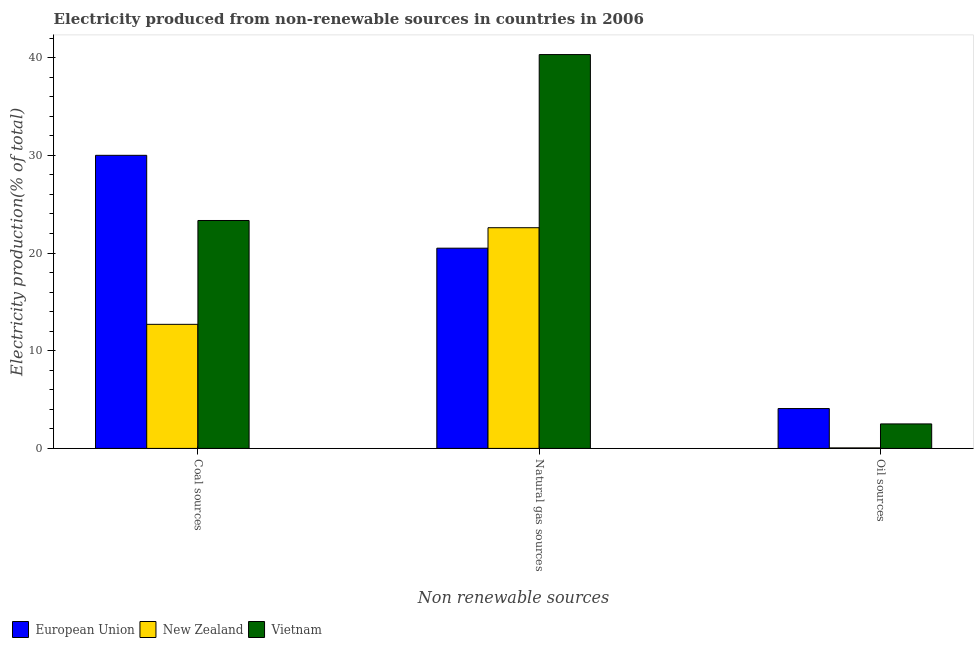How many different coloured bars are there?
Keep it short and to the point. 3. How many groups of bars are there?
Give a very brief answer. 3. Are the number of bars on each tick of the X-axis equal?
Offer a terse response. Yes. How many bars are there on the 3rd tick from the left?
Your answer should be very brief. 3. What is the label of the 3rd group of bars from the left?
Your response must be concise. Oil sources. What is the percentage of electricity produced by natural gas in Vietnam?
Ensure brevity in your answer.  40.32. Across all countries, what is the maximum percentage of electricity produced by oil sources?
Offer a terse response. 4.08. Across all countries, what is the minimum percentage of electricity produced by oil sources?
Your answer should be compact. 0.05. In which country was the percentage of electricity produced by oil sources maximum?
Offer a terse response. European Union. In which country was the percentage of electricity produced by coal minimum?
Make the answer very short. New Zealand. What is the total percentage of electricity produced by oil sources in the graph?
Offer a terse response. 6.64. What is the difference between the percentage of electricity produced by oil sources in European Union and that in New Zealand?
Offer a very short reply. 4.03. What is the difference between the percentage of electricity produced by oil sources in European Union and the percentage of electricity produced by natural gas in New Zealand?
Keep it short and to the point. -18.51. What is the average percentage of electricity produced by natural gas per country?
Your answer should be compact. 27.8. What is the difference between the percentage of electricity produced by coal and percentage of electricity produced by natural gas in Vietnam?
Offer a very short reply. -16.99. What is the ratio of the percentage of electricity produced by coal in New Zealand to that in European Union?
Provide a succinct answer. 0.42. What is the difference between the highest and the second highest percentage of electricity produced by natural gas?
Your answer should be very brief. 17.72. What is the difference between the highest and the lowest percentage of electricity produced by coal?
Ensure brevity in your answer.  17.3. In how many countries, is the percentage of electricity produced by coal greater than the average percentage of electricity produced by coal taken over all countries?
Your response must be concise. 2. Is the sum of the percentage of electricity produced by oil sources in Vietnam and New Zealand greater than the maximum percentage of electricity produced by natural gas across all countries?
Provide a succinct answer. No. What does the 3rd bar from the left in Natural gas sources represents?
Offer a terse response. Vietnam. What does the 2nd bar from the right in Natural gas sources represents?
Provide a short and direct response. New Zealand. Is it the case that in every country, the sum of the percentage of electricity produced by coal and percentage of electricity produced by natural gas is greater than the percentage of electricity produced by oil sources?
Offer a very short reply. Yes. How many bars are there?
Offer a terse response. 9. Are all the bars in the graph horizontal?
Offer a very short reply. No. Are the values on the major ticks of Y-axis written in scientific E-notation?
Give a very brief answer. No. Does the graph contain any zero values?
Give a very brief answer. No. Does the graph contain grids?
Make the answer very short. No. Where does the legend appear in the graph?
Make the answer very short. Bottom left. How many legend labels are there?
Your answer should be compact. 3. How are the legend labels stacked?
Your answer should be compact. Horizontal. What is the title of the graph?
Your answer should be very brief. Electricity produced from non-renewable sources in countries in 2006. Does "Haiti" appear as one of the legend labels in the graph?
Your answer should be very brief. No. What is the label or title of the X-axis?
Give a very brief answer. Non renewable sources. What is the Electricity production(% of total) of European Union in Coal sources?
Offer a terse response. 30. What is the Electricity production(% of total) of New Zealand in Coal sources?
Provide a succinct answer. 12.7. What is the Electricity production(% of total) in Vietnam in Coal sources?
Provide a succinct answer. 23.33. What is the Electricity production(% of total) of European Union in Natural gas sources?
Ensure brevity in your answer.  20.5. What is the Electricity production(% of total) of New Zealand in Natural gas sources?
Make the answer very short. 22.59. What is the Electricity production(% of total) in Vietnam in Natural gas sources?
Your answer should be compact. 40.32. What is the Electricity production(% of total) in European Union in Oil sources?
Offer a very short reply. 4.08. What is the Electricity production(% of total) of New Zealand in Oil sources?
Your response must be concise. 0.05. What is the Electricity production(% of total) in Vietnam in Oil sources?
Give a very brief answer. 2.51. Across all Non renewable sources, what is the maximum Electricity production(% of total) of European Union?
Make the answer very short. 30. Across all Non renewable sources, what is the maximum Electricity production(% of total) of New Zealand?
Your response must be concise. 22.59. Across all Non renewable sources, what is the maximum Electricity production(% of total) of Vietnam?
Give a very brief answer. 40.32. Across all Non renewable sources, what is the minimum Electricity production(% of total) of European Union?
Your answer should be very brief. 4.08. Across all Non renewable sources, what is the minimum Electricity production(% of total) in New Zealand?
Provide a short and direct response. 0.05. Across all Non renewable sources, what is the minimum Electricity production(% of total) in Vietnam?
Offer a very short reply. 2.51. What is the total Electricity production(% of total) of European Union in the graph?
Ensure brevity in your answer.  54.58. What is the total Electricity production(% of total) of New Zealand in the graph?
Ensure brevity in your answer.  35.35. What is the total Electricity production(% of total) in Vietnam in the graph?
Offer a very short reply. 66.16. What is the difference between the Electricity production(% of total) of European Union in Coal sources and that in Natural gas sources?
Ensure brevity in your answer.  9.51. What is the difference between the Electricity production(% of total) of New Zealand in Coal sources and that in Natural gas sources?
Keep it short and to the point. -9.89. What is the difference between the Electricity production(% of total) in Vietnam in Coal sources and that in Natural gas sources?
Your answer should be very brief. -16.99. What is the difference between the Electricity production(% of total) of European Union in Coal sources and that in Oil sources?
Provide a short and direct response. 25.92. What is the difference between the Electricity production(% of total) in New Zealand in Coal sources and that in Oil sources?
Provide a short and direct response. 12.65. What is the difference between the Electricity production(% of total) in Vietnam in Coal sources and that in Oil sources?
Your answer should be compact. 20.82. What is the difference between the Electricity production(% of total) of European Union in Natural gas sources and that in Oil sources?
Give a very brief answer. 16.42. What is the difference between the Electricity production(% of total) of New Zealand in Natural gas sources and that in Oil sources?
Give a very brief answer. 22.54. What is the difference between the Electricity production(% of total) of Vietnam in Natural gas sources and that in Oil sources?
Keep it short and to the point. 37.81. What is the difference between the Electricity production(% of total) in European Union in Coal sources and the Electricity production(% of total) in New Zealand in Natural gas sources?
Keep it short and to the point. 7.41. What is the difference between the Electricity production(% of total) of European Union in Coal sources and the Electricity production(% of total) of Vietnam in Natural gas sources?
Provide a succinct answer. -10.31. What is the difference between the Electricity production(% of total) in New Zealand in Coal sources and the Electricity production(% of total) in Vietnam in Natural gas sources?
Your response must be concise. -27.62. What is the difference between the Electricity production(% of total) in European Union in Coal sources and the Electricity production(% of total) in New Zealand in Oil sources?
Provide a short and direct response. 29.95. What is the difference between the Electricity production(% of total) in European Union in Coal sources and the Electricity production(% of total) in Vietnam in Oil sources?
Offer a terse response. 27.5. What is the difference between the Electricity production(% of total) in New Zealand in Coal sources and the Electricity production(% of total) in Vietnam in Oil sources?
Provide a succinct answer. 10.19. What is the difference between the Electricity production(% of total) of European Union in Natural gas sources and the Electricity production(% of total) of New Zealand in Oil sources?
Provide a short and direct response. 20.44. What is the difference between the Electricity production(% of total) of European Union in Natural gas sources and the Electricity production(% of total) of Vietnam in Oil sources?
Offer a terse response. 17.99. What is the difference between the Electricity production(% of total) of New Zealand in Natural gas sources and the Electricity production(% of total) of Vietnam in Oil sources?
Provide a short and direct response. 20.09. What is the average Electricity production(% of total) in European Union per Non renewable sources?
Offer a very short reply. 18.19. What is the average Electricity production(% of total) in New Zealand per Non renewable sources?
Make the answer very short. 11.78. What is the average Electricity production(% of total) in Vietnam per Non renewable sources?
Your answer should be very brief. 22.05. What is the difference between the Electricity production(% of total) of European Union and Electricity production(% of total) of New Zealand in Coal sources?
Provide a succinct answer. 17.3. What is the difference between the Electricity production(% of total) in European Union and Electricity production(% of total) in Vietnam in Coal sources?
Ensure brevity in your answer.  6.67. What is the difference between the Electricity production(% of total) of New Zealand and Electricity production(% of total) of Vietnam in Coal sources?
Ensure brevity in your answer.  -10.63. What is the difference between the Electricity production(% of total) in European Union and Electricity production(% of total) in New Zealand in Natural gas sources?
Provide a succinct answer. -2.1. What is the difference between the Electricity production(% of total) of European Union and Electricity production(% of total) of Vietnam in Natural gas sources?
Offer a terse response. -19.82. What is the difference between the Electricity production(% of total) in New Zealand and Electricity production(% of total) in Vietnam in Natural gas sources?
Offer a terse response. -17.72. What is the difference between the Electricity production(% of total) in European Union and Electricity production(% of total) in New Zealand in Oil sources?
Your answer should be very brief. 4.03. What is the difference between the Electricity production(% of total) in European Union and Electricity production(% of total) in Vietnam in Oil sources?
Ensure brevity in your answer.  1.57. What is the difference between the Electricity production(% of total) of New Zealand and Electricity production(% of total) of Vietnam in Oil sources?
Give a very brief answer. -2.46. What is the ratio of the Electricity production(% of total) in European Union in Coal sources to that in Natural gas sources?
Your response must be concise. 1.46. What is the ratio of the Electricity production(% of total) of New Zealand in Coal sources to that in Natural gas sources?
Keep it short and to the point. 0.56. What is the ratio of the Electricity production(% of total) in Vietnam in Coal sources to that in Natural gas sources?
Your answer should be very brief. 0.58. What is the ratio of the Electricity production(% of total) in European Union in Coal sources to that in Oil sources?
Provide a short and direct response. 7.35. What is the ratio of the Electricity production(% of total) in New Zealand in Coal sources to that in Oil sources?
Give a very brief answer. 240.78. What is the ratio of the Electricity production(% of total) in Vietnam in Coal sources to that in Oil sources?
Make the answer very short. 9.3. What is the ratio of the Electricity production(% of total) of European Union in Natural gas sources to that in Oil sources?
Your answer should be compact. 5.02. What is the ratio of the Electricity production(% of total) of New Zealand in Natural gas sources to that in Oil sources?
Your answer should be very brief. 428.3. What is the ratio of the Electricity production(% of total) of Vietnam in Natural gas sources to that in Oil sources?
Provide a succinct answer. 16.08. What is the difference between the highest and the second highest Electricity production(% of total) in European Union?
Ensure brevity in your answer.  9.51. What is the difference between the highest and the second highest Electricity production(% of total) in New Zealand?
Ensure brevity in your answer.  9.89. What is the difference between the highest and the second highest Electricity production(% of total) in Vietnam?
Provide a short and direct response. 16.99. What is the difference between the highest and the lowest Electricity production(% of total) in European Union?
Keep it short and to the point. 25.92. What is the difference between the highest and the lowest Electricity production(% of total) of New Zealand?
Ensure brevity in your answer.  22.54. What is the difference between the highest and the lowest Electricity production(% of total) in Vietnam?
Offer a terse response. 37.81. 